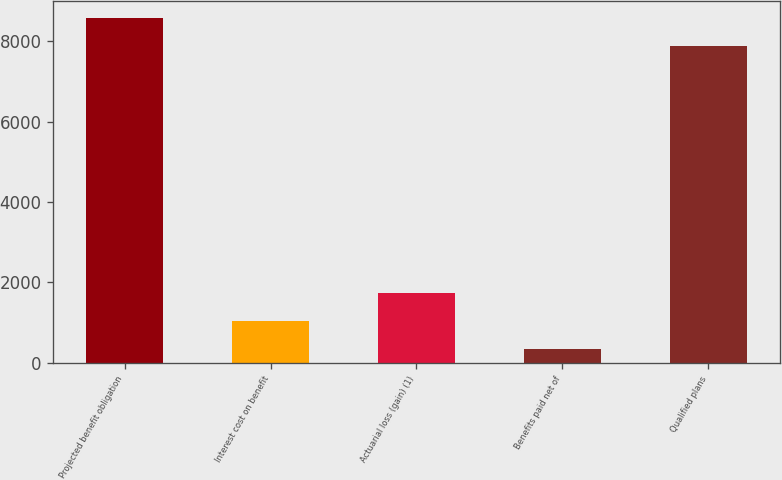Convert chart. <chart><loc_0><loc_0><loc_500><loc_500><bar_chart><fcel>Projected benefit obligation<fcel>Interest cost on benefit<fcel>Actuarial loss (gain) (1)<fcel>Benefits paid net of<fcel>Qualified plans<nl><fcel>8574<fcel>1042<fcel>1732<fcel>352<fcel>7884<nl></chart> 